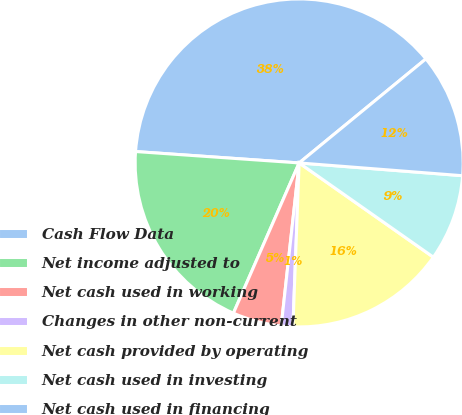<chart> <loc_0><loc_0><loc_500><loc_500><pie_chart><fcel>Cash Flow Data<fcel>Net income adjusted to<fcel>Net cash used in working<fcel>Changes in other non-current<fcel>Net cash provided by operating<fcel>Net cash used in investing<fcel>Net cash used in financing<nl><fcel>37.95%<fcel>19.54%<fcel>4.82%<fcel>1.14%<fcel>15.86%<fcel>8.5%<fcel>12.18%<nl></chart> 